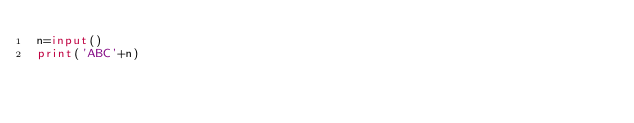<code> <loc_0><loc_0><loc_500><loc_500><_Python_>n=input()
print('ABC'+n)</code> 